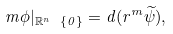Convert formula to latex. <formula><loc_0><loc_0><loc_500><loc_500>m \phi | _ { \mathbb { R } ^ { n } \ \{ 0 \} } = d ( r ^ { m } \widetilde { \psi } ) ,</formula> 